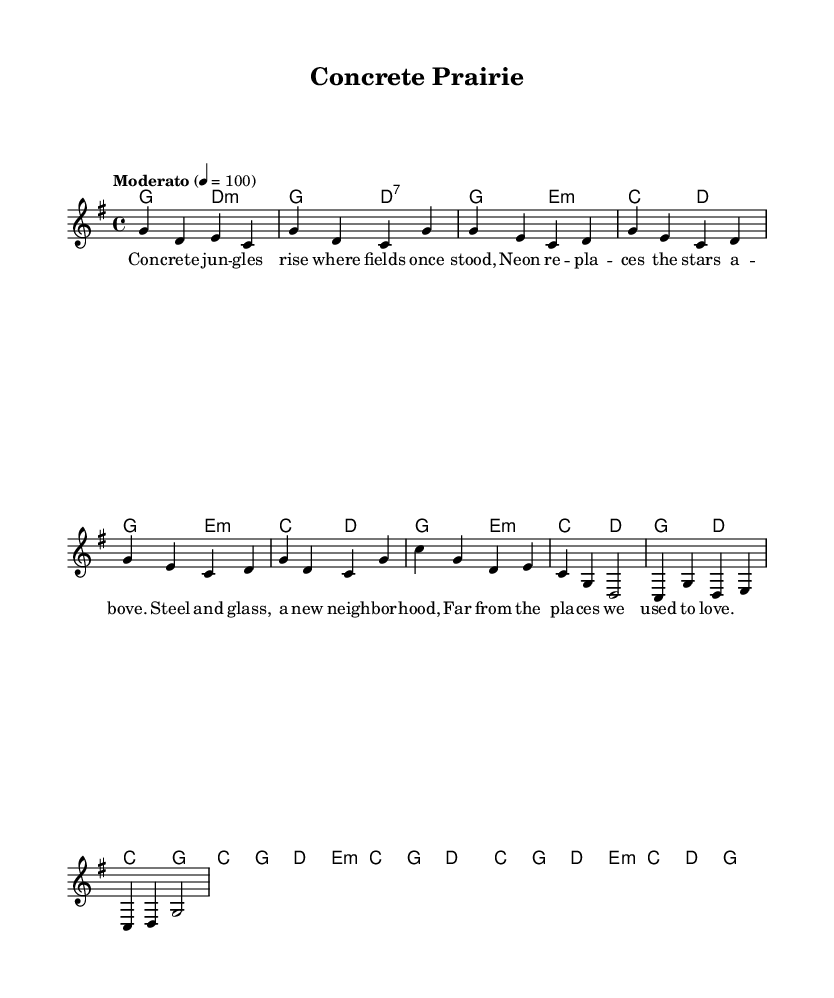What is the key signature of this music? The key signature is G major, which has one sharp (F#).
Answer: G major What is the time signature of this piece? The time signature indicated is 4/4, meaning there are four beats in each measure, and the quarter note gets one beat.
Answer: 4/4 What is the tempo marking for this composition? The tempo marking is "Moderato," which suggests a moderate pace, specifically set to 100 beats per minute.
Answer: Moderato How many measures are in the chorus section? By counting the measures in the chorus section, there are 4 distinct measures present.
Answer: 4 What is the first chord played in the introduction? The first chord indicated in the introduction is G major, as shown in the harmonies section.
Answer: G major What is the overall theme expressed in the lyrics of the first verse? The lyrics discuss urban development and the contrast between the old and the new environments, reflecting on cultural adaptation in the city.
Answer: Urban development How does the harmony change during the chorus compared to the verse? In the chorus, the harmonic structure shifts to emphasize the C major chord followed by G and E minor, creating a strong resolution as compared to the more varied chords in the verse.
Answer: Emphasis on C major 